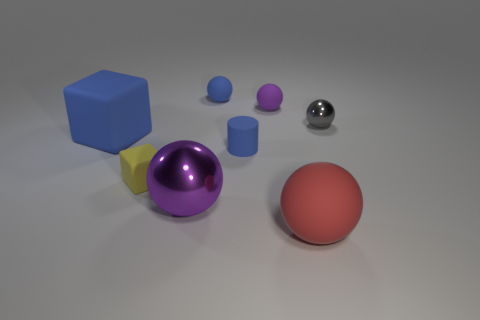Subtract 1 spheres. How many spheres are left? 4 Subtract all blue spheres. How many spheres are left? 4 Subtract all red balls. How many balls are left? 4 Subtract all blue spheres. Subtract all red blocks. How many spheres are left? 4 Add 1 large brown shiny things. How many objects exist? 9 Subtract all balls. How many objects are left? 3 Add 7 big things. How many big things are left? 10 Add 2 tiny matte balls. How many tiny matte balls exist? 4 Subtract 1 red balls. How many objects are left? 7 Subtract all big purple blocks. Subtract all tiny blocks. How many objects are left? 7 